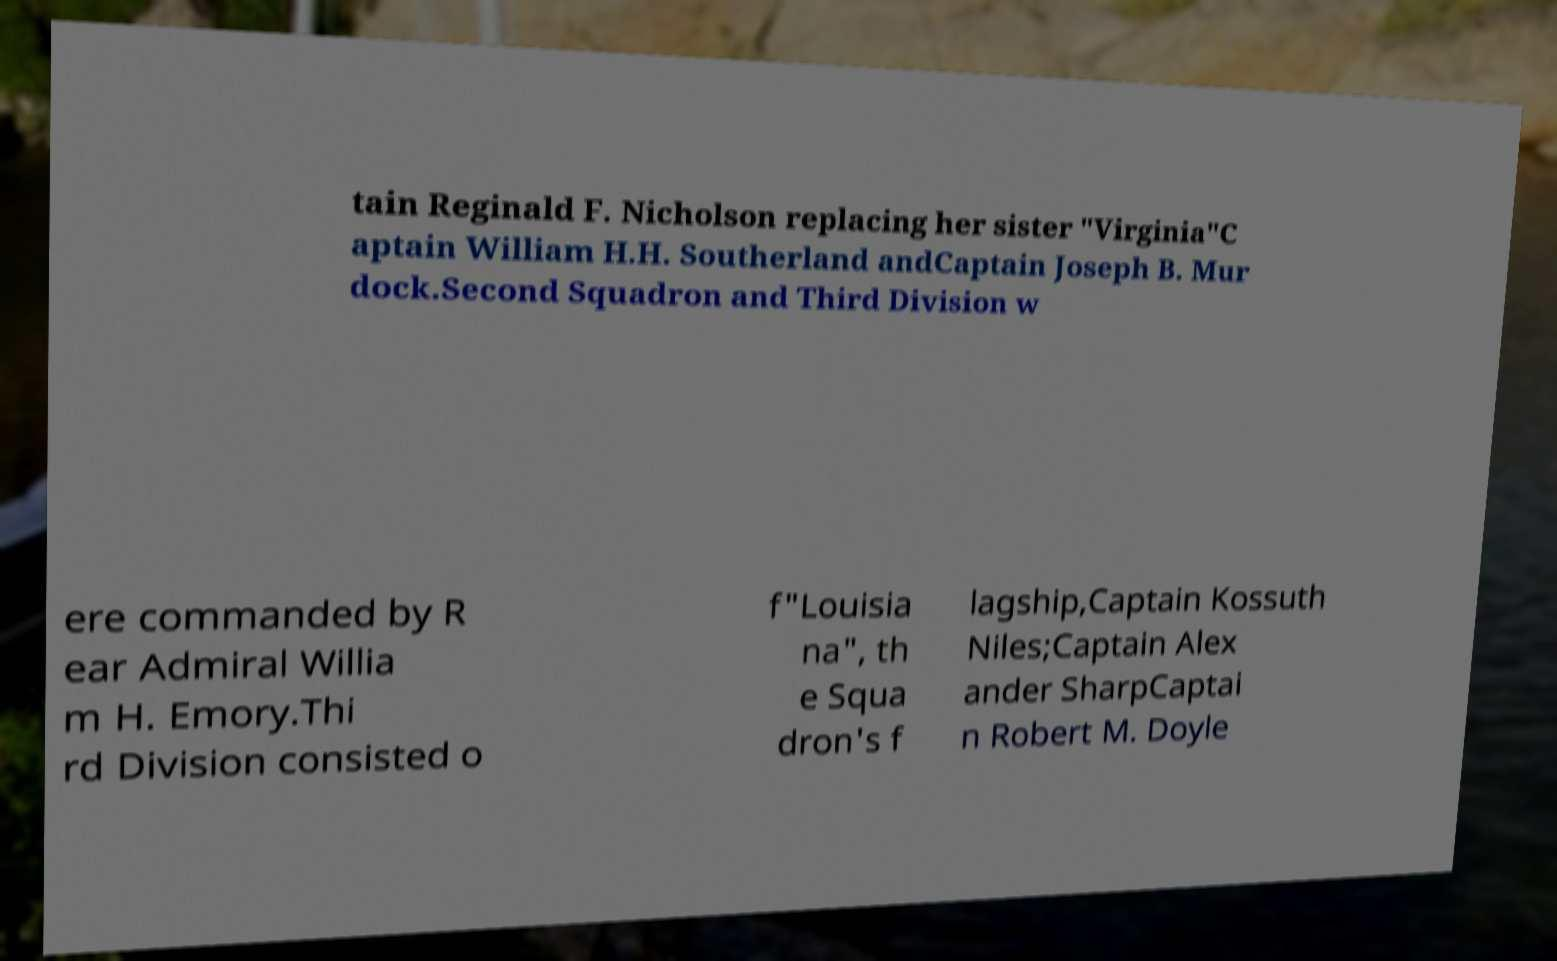Could you assist in decoding the text presented in this image and type it out clearly? tain Reginald F. Nicholson replacing her sister "Virginia"C aptain William H.H. Southerland andCaptain Joseph B. Mur dock.Second Squadron and Third Division w ere commanded by R ear Admiral Willia m H. Emory.Thi rd Division consisted o f"Louisia na", th e Squa dron's f lagship,Captain Kossuth Niles;Captain Alex ander SharpCaptai n Robert M. Doyle 